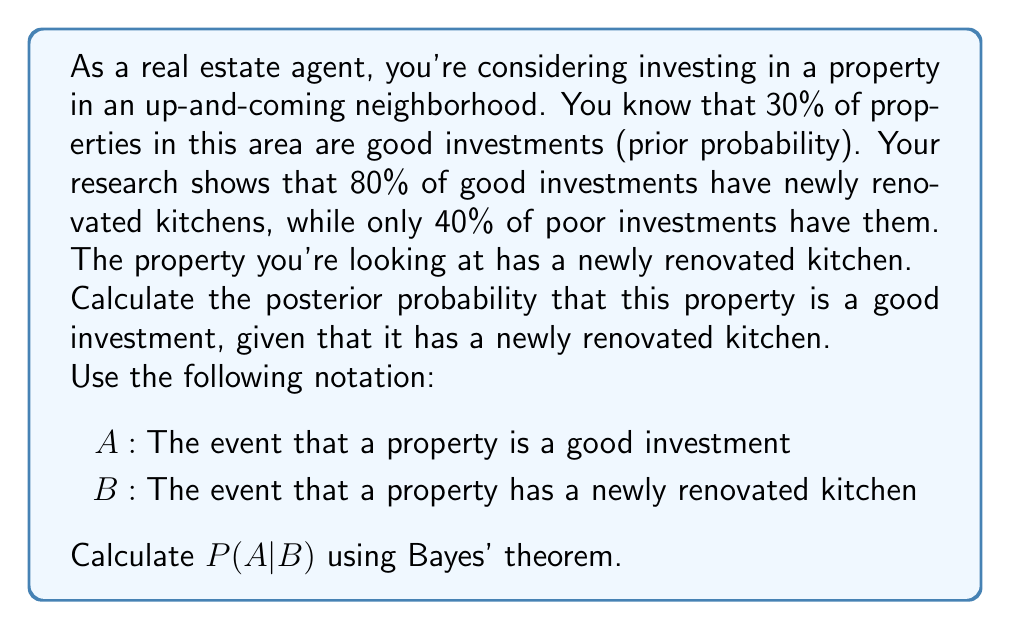Could you help me with this problem? To solve this problem, we'll use Bayes' theorem:

$$P(A|B) = \frac{P(B|A) \cdot P(A)}{P(B)}$$

Given:
- $P(A) = 0.30$ (prior probability of a good investment)
- $P(B|A) = 0.80$ (probability of a newly renovated kitchen given a good investment)
- $P(B|\neg A) = 0.40$ (probability of a newly renovated kitchen given a poor investment)

Step 1: Calculate $P(B)$ using the law of total probability:
$$P(B) = P(B|A) \cdot P(A) + P(B|\neg A) \cdot P(\neg A)$$
$$P(B) = 0.80 \cdot 0.30 + 0.40 \cdot 0.70 = 0.24 + 0.28 = 0.52$$

Step 2: Apply Bayes' theorem:
$$P(A|B) = \frac{P(B|A) \cdot P(A)}{P(B)}$$
$$P(A|B) = \frac{0.80 \cdot 0.30}{0.52}$$
$$P(A|B) = \frac{0.24}{0.52} \approx 0.4615$$

Step 3: Convert to a percentage:
$$P(A|B) \approx 0.4615 \cdot 100\% = 46.15\%$$

Therefore, the posterior probability that the property is a good investment, given that it has a newly renovated kitchen, is approximately 46.15%.
Answer: 46.15% 